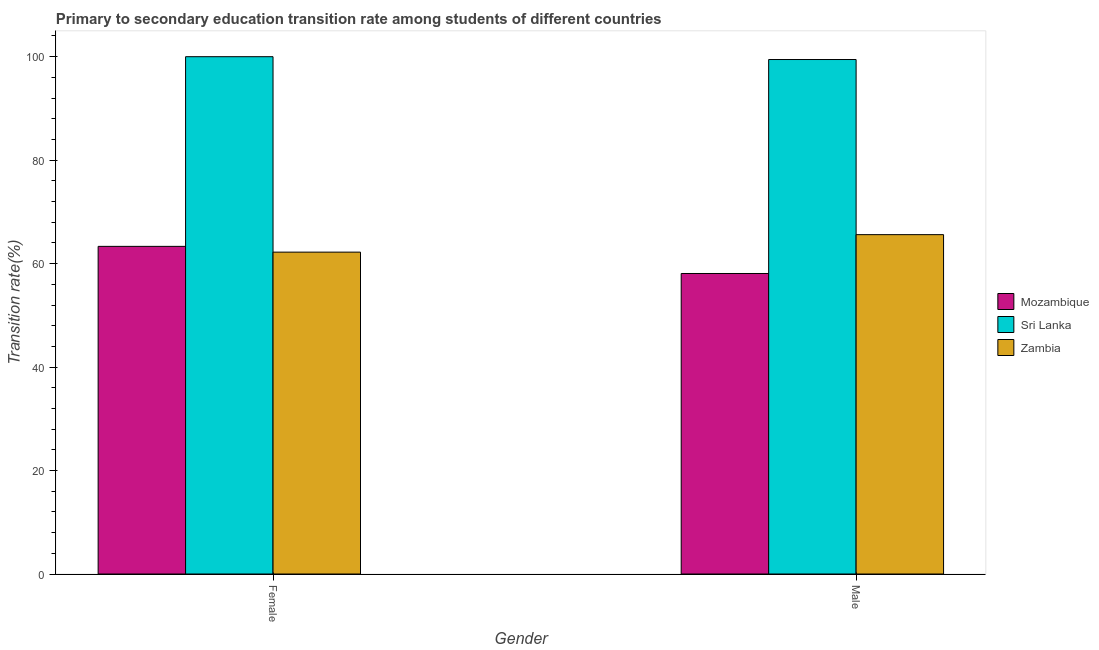How many groups of bars are there?
Offer a very short reply. 2. Are the number of bars on each tick of the X-axis equal?
Provide a succinct answer. Yes. How many bars are there on the 2nd tick from the left?
Offer a very short reply. 3. How many bars are there on the 2nd tick from the right?
Offer a very short reply. 3. What is the label of the 2nd group of bars from the left?
Give a very brief answer. Male. What is the transition rate among female students in Sri Lanka?
Provide a short and direct response. 100. Across all countries, what is the maximum transition rate among male students?
Your response must be concise. 99.45. Across all countries, what is the minimum transition rate among male students?
Give a very brief answer. 58.09. In which country was the transition rate among female students maximum?
Provide a succinct answer. Sri Lanka. In which country was the transition rate among female students minimum?
Give a very brief answer. Zambia. What is the total transition rate among female students in the graph?
Provide a succinct answer. 225.56. What is the difference between the transition rate among female students in Mozambique and that in Zambia?
Your answer should be compact. 1.11. What is the difference between the transition rate among male students in Mozambique and the transition rate among female students in Zambia?
Ensure brevity in your answer.  -4.13. What is the average transition rate among female students per country?
Your answer should be very brief. 75.19. What is the difference between the transition rate among male students and transition rate among female students in Zambia?
Provide a short and direct response. 3.38. In how many countries, is the transition rate among male students greater than 84 %?
Your response must be concise. 1. What is the ratio of the transition rate among male students in Mozambique to that in Zambia?
Offer a very short reply. 0.89. Is the transition rate among male students in Mozambique less than that in Zambia?
Provide a succinct answer. Yes. In how many countries, is the transition rate among male students greater than the average transition rate among male students taken over all countries?
Offer a terse response. 1. What does the 1st bar from the left in Male represents?
Your answer should be compact. Mozambique. What does the 3rd bar from the right in Male represents?
Give a very brief answer. Mozambique. How many bars are there?
Your response must be concise. 6. How many countries are there in the graph?
Offer a terse response. 3. Are the values on the major ticks of Y-axis written in scientific E-notation?
Offer a terse response. No. Does the graph contain any zero values?
Offer a very short reply. No. Does the graph contain grids?
Offer a terse response. No. Where does the legend appear in the graph?
Your response must be concise. Center right. How many legend labels are there?
Provide a short and direct response. 3. What is the title of the graph?
Your answer should be very brief. Primary to secondary education transition rate among students of different countries. Does "Djibouti" appear as one of the legend labels in the graph?
Provide a succinct answer. No. What is the label or title of the Y-axis?
Make the answer very short. Transition rate(%). What is the Transition rate(%) of Mozambique in Female?
Provide a short and direct response. 63.34. What is the Transition rate(%) in Zambia in Female?
Offer a terse response. 62.22. What is the Transition rate(%) of Mozambique in Male?
Give a very brief answer. 58.09. What is the Transition rate(%) in Sri Lanka in Male?
Give a very brief answer. 99.45. What is the Transition rate(%) in Zambia in Male?
Offer a very short reply. 65.6. Across all Gender, what is the maximum Transition rate(%) of Mozambique?
Your answer should be very brief. 63.34. Across all Gender, what is the maximum Transition rate(%) in Sri Lanka?
Your answer should be very brief. 100. Across all Gender, what is the maximum Transition rate(%) in Zambia?
Your answer should be compact. 65.6. Across all Gender, what is the minimum Transition rate(%) of Mozambique?
Offer a very short reply. 58.09. Across all Gender, what is the minimum Transition rate(%) of Sri Lanka?
Ensure brevity in your answer.  99.45. Across all Gender, what is the minimum Transition rate(%) in Zambia?
Give a very brief answer. 62.22. What is the total Transition rate(%) of Mozambique in the graph?
Make the answer very short. 121.43. What is the total Transition rate(%) of Sri Lanka in the graph?
Provide a succinct answer. 199.45. What is the total Transition rate(%) of Zambia in the graph?
Provide a succinct answer. 127.82. What is the difference between the Transition rate(%) in Mozambique in Female and that in Male?
Provide a succinct answer. 5.24. What is the difference between the Transition rate(%) of Sri Lanka in Female and that in Male?
Offer a very short reply. 0.55. What is the difference between the Transition rate(%) in Zambia in Female and that in Male?
Your answer should be very brief. -3.38. What is the difference between the Transition rate(%) in Mozambique in Female and the Transition rate(%) in Sri Lanka in Male?
Make the answer very short. -36.12. What is the difference between the Transition rate(%) of Mozambique in Female and the Transition rate(%) of Zambia in Male?
Your answer should be very brief. -2.26. What is the difference between the Transition rate(%) in Sri Lanka in Female and the Transition rate(%) in Zambia in Male?
Offer a very short reply. 34.4. What is the average Transition rate(%) of Mozambique per Gender?
Give a very brief answer. 60.71. What is the average Transition rate(%) in Sri Lanka per Gender?
Make the answer very short. 99.73. What is the average Transition rate(%) of Zambia per Gender?
Offer a terse response. 63.91. What is the difference between the Transition rate(%) in Mozambique and Transition rate(%) in Sri Lanka in Female?
Provide a short and direct response. -36.66. What is the difference between the Transition rate(%) in Mozambique and Transition rate(%) in Zambia in Female?
Your answer should be compact. 1.11. What is the difference between the Transition rate(%) in Sri Lanka and Transition rate(%) in Zambia in Female?
Provide a succinct answer. 37.78. What is the difference between the Transition rate(%) in Mozambique and Transition rate(%) in Sri Lanka in Male?
Ensure brevity in your answer.  -41.36. What is the difference between the Transition rate(%) in Mozambique and Transition rate(%) in Zambia in Male?
Keep it short and to the point. -7.51. What is the difference between the Transition rate(%) of Sri Lanka and Transition rate(%) of Zambia in Male?
Your response must be concise. 33.85. What is the ratio of the Transition rate(%) of Mozambique in Female to that in Male?
Keep it short and to the point. 1.09. What is the ratio of the Transition rate(%) of Sri Lanka in Female to that in Male?
Offer a very short reply. 1.01. What is the ratio of the Transition rate(%) in Zambia in Female to that in Male?
Keep it short and to the point. 0.95. What is the difference between the highest and the second highest Transition rate(%) of Mozambique?
Keep it short and to the point. 5.24. What is the difference between the highest and the second highest Transition rate(%) in Sri Lanka?
Your response must be concise. 0.55. What is the difference between the highest and the second highest Transition rate(%) of Zambia?
Offer a very short reply. 3.38. What is the difference between the highest and the lowest Transition rate(%) of Mozambique?
Give a very brief answer. 5.24. What is the difference between the highest and the lowest Transition rate(%) in Sri Lanka?
Keep it short and to the point. 0.55. What is the difference between the highest and the lowest Transition rate(%) of Zambia?
Provide a short and direct response. 3.38. 